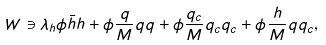<formula> <loc_0><loc_0><loc_500><loc_500>W \ni \lambda _ { h } \phi \bar { h } h + \phi \frac { q } { M } q q + \phi \frac { q _ { c } } { M } q _ { c } q _ { c } + \phi \frac { h } { M } q q _ { c } ,</formula> 